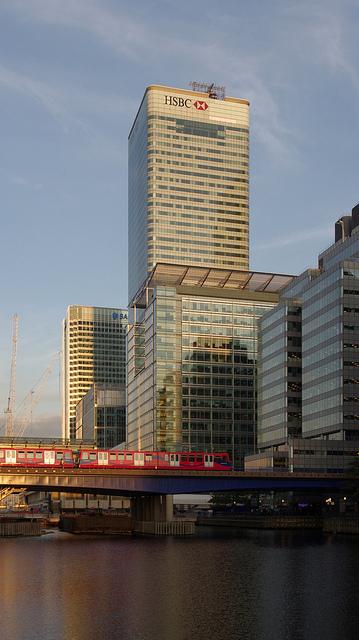Is the bridge tall enough for a large sailboard to pass under?
Write a very short answer. No. How many floors does the tall building have?
Quick response, please. 40. What is the name on the top of the tall building?
Quick response, please. Hsbc. Is this daytime?
Write a very short answer. Yes. Was this photograph taken in the AM or the PM?
Give a very brief answer. Pm. What is the name of the hotel in the background?
Answer briefly. Hsbc. Is there a car under the bridge?
Short answer required. No. 